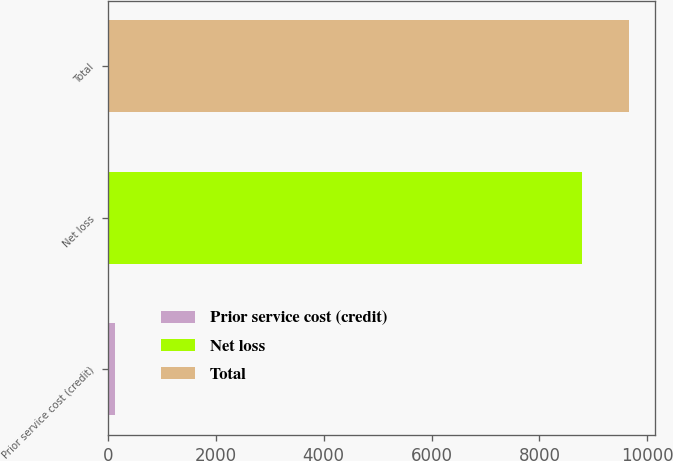Convert chart to OTSL. <chart><loc_0><loc_0><loc_500><loc_500><bar_chart><fcel>Prior service cost (credit)<fcel>Net loss<fcel>Total<nl><fcel>127<fcel>8781<fcel>9659.1<nl></chart> 